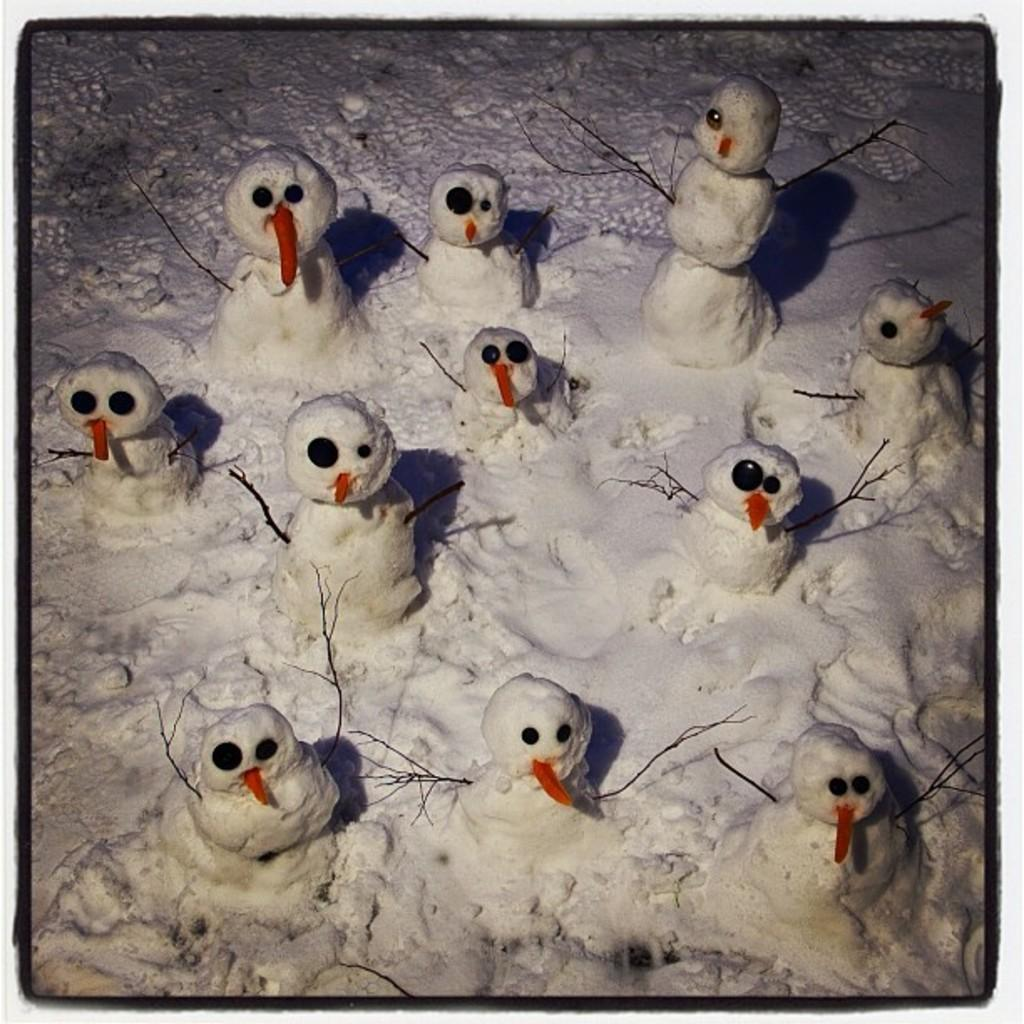What is the main subject of the image? There is a snowman in the image. Where is the snowman located? The snowman is on the snow. What type of prose is being recited by the snowman in the image? There is no indication in the image that the snowman is reciting any prose, as snowmen are inanimate objects and cannot speak or recite literature. 